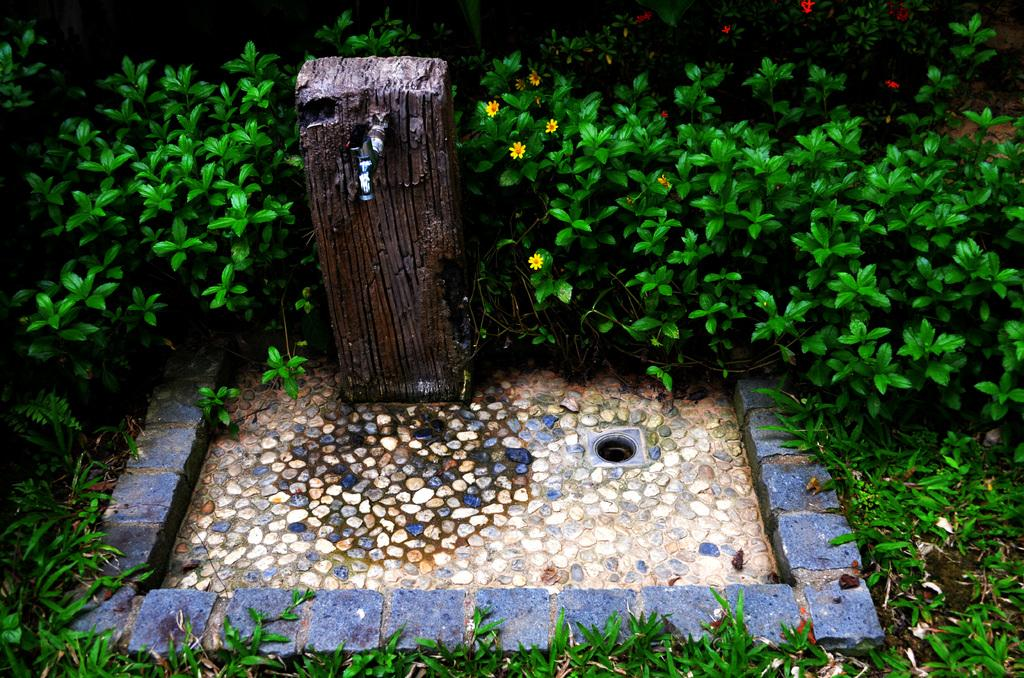What is located on the ground in the image? There is an object on the ground in the image. What can be seen in the background of the image? There are plants and flowers in the background of the image. What type of trousers can be seen hanging from the tree in the image? There are no trousers present in the image, nor is there a tree depicted. 